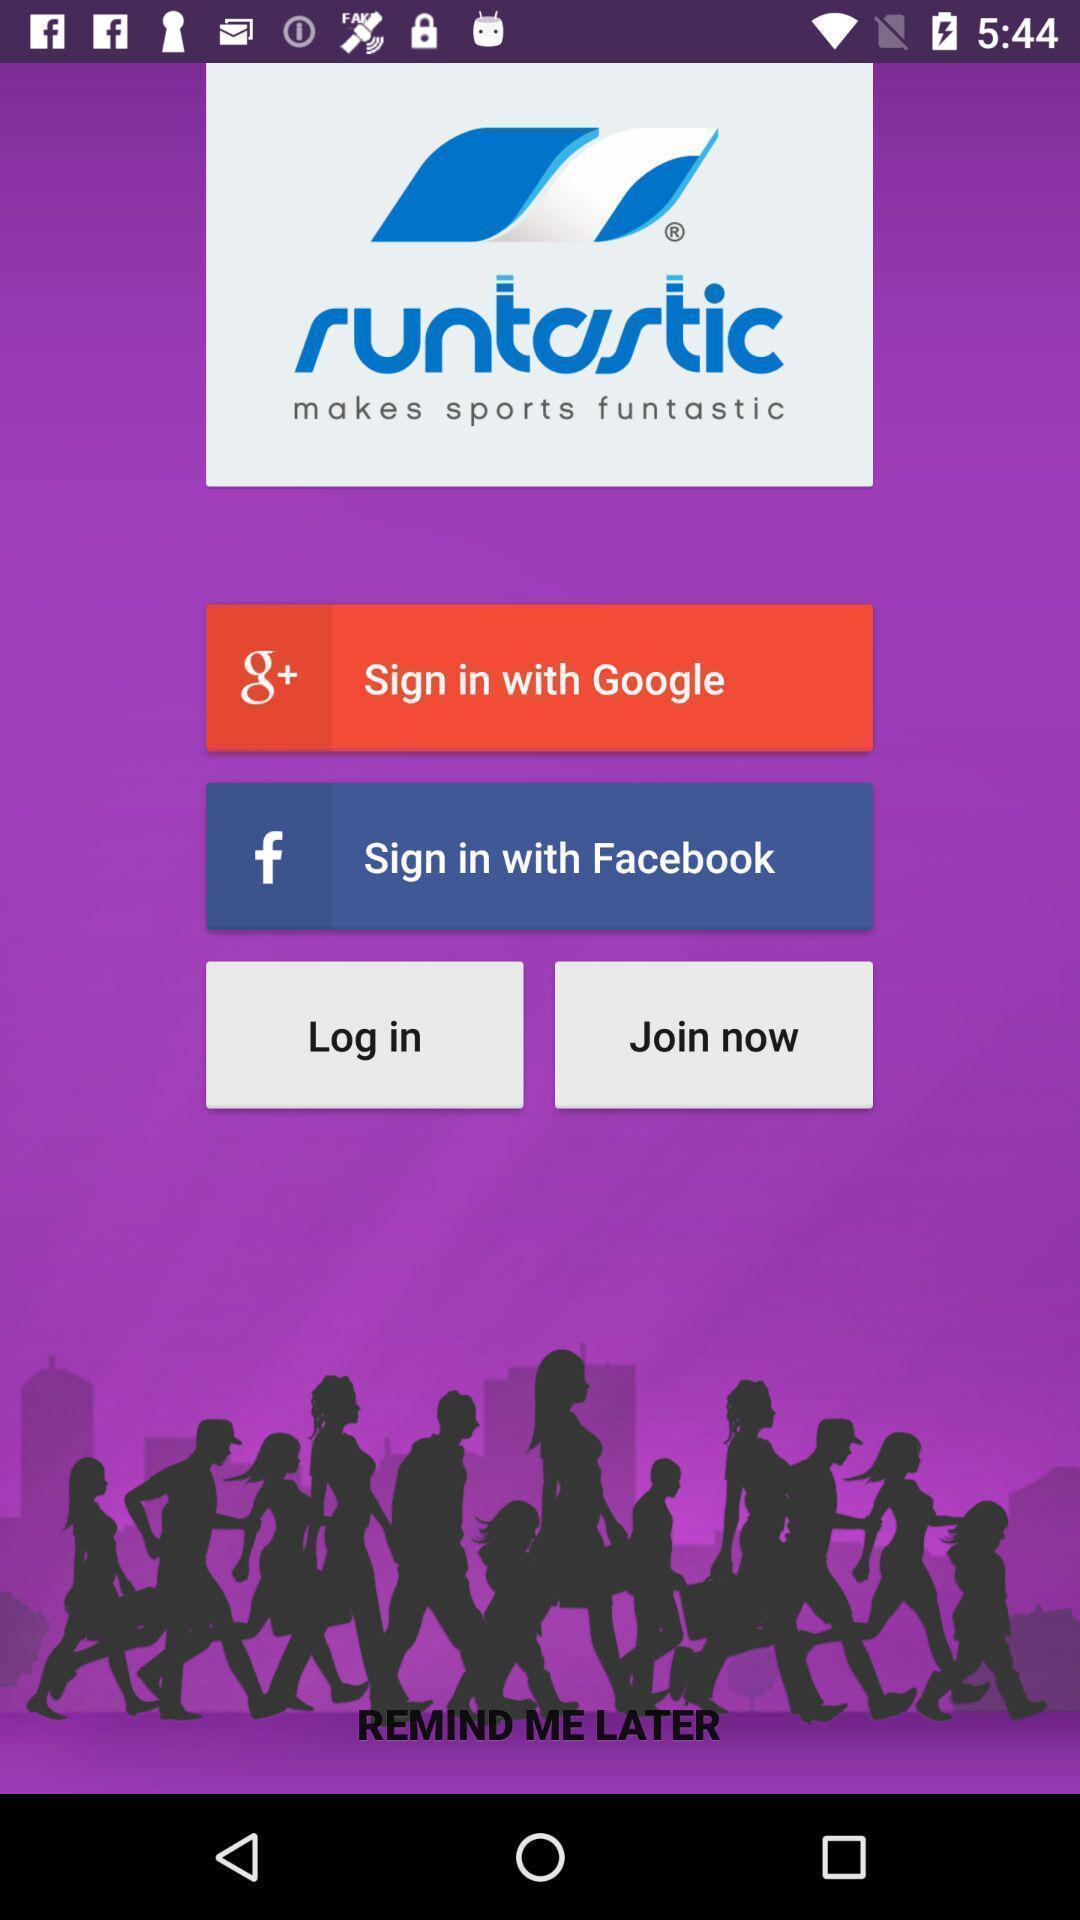Give me a narrative description of this picture. Welcome page displaying to join or login to the application. 